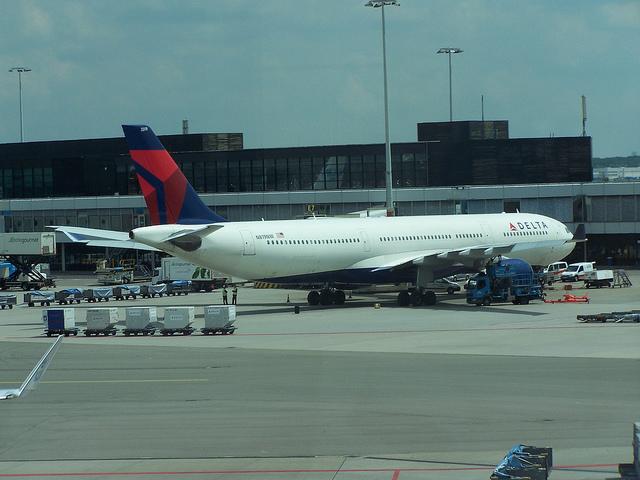What airline is on the plane?
Keep it brief. Delta. Is this an airport?
Concise answer only. Yes. Is the plane in motion?
Short answer required. No. 